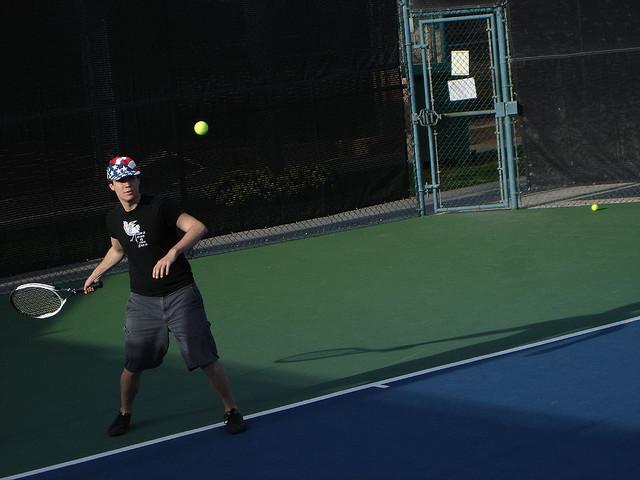Does this man have a shadow?
Answer briefly. Yes. Does this man play tennis for a living?
Keep it brief. No. What is the man doing?
Short answer required. Playing tennis. What clothing brand logo is seen here?
Answer briefly. Unknown. Will this person get hit in the face?
Keep it brief. No. Where is the red/white and blue cap?
Short answer required. Head. What is illuminating the tennis court?
Give a very brief answer. Sun. 